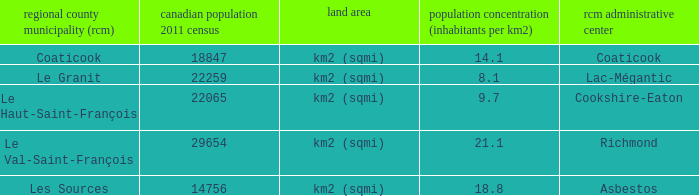What is the seat of the county that has a density of 14.1? Coaticook. 